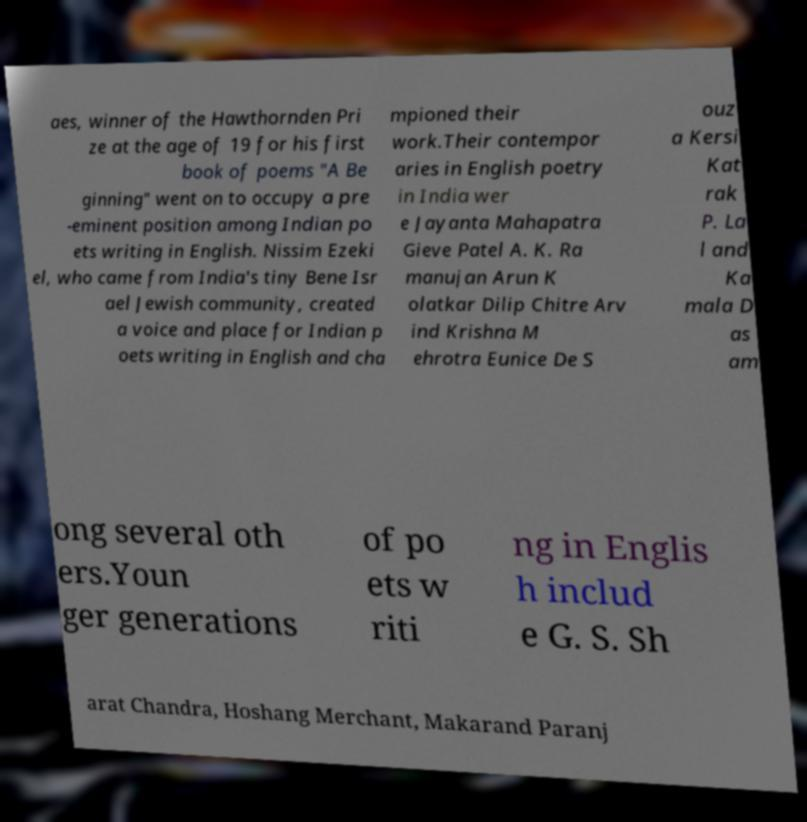Please read and relay the text visible in this image. What does it say? aes, winner of the Hawthornden Pri ze at the age of 19 for his first book of poems "A Be ginning" went on to occupy a pre -eminent position among Indian po ets writing in English. Nissim Ezeki el, who came from India's tiny Bene Isr ael Jewish community, created a voice and place for Indian p oets writing in English and cha mpioned their work.Their contempor aries in English poetry in India wer e Jayanta Mahapatra Gieve Patel A. K. Ra manujan Arun K olatkar Dilip Chitre Arv ind Krishna M ehrotra Eunice De S ouz a Kersi Kat rak P. La l and Ka mala D as am ong several oth ers.Youn ger generations of po ets w riti ng in Englis h includ e G. S. Sh arat Chandra, Hoshang Merchant, Makarand Paranj 